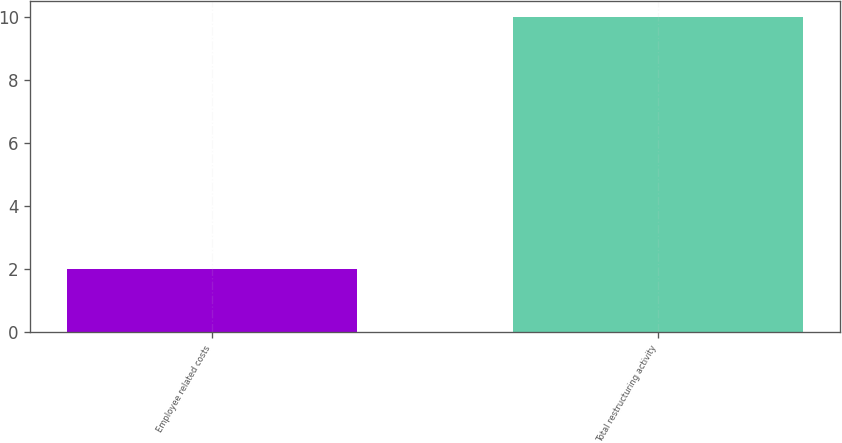<chart> <loc_0><loc_0><loc_500><loc_500><bar_chart><fcel>Employee related costs<fcel>Total restructuring activity<nl><fcel>2<fcel>10<nl></chart> 